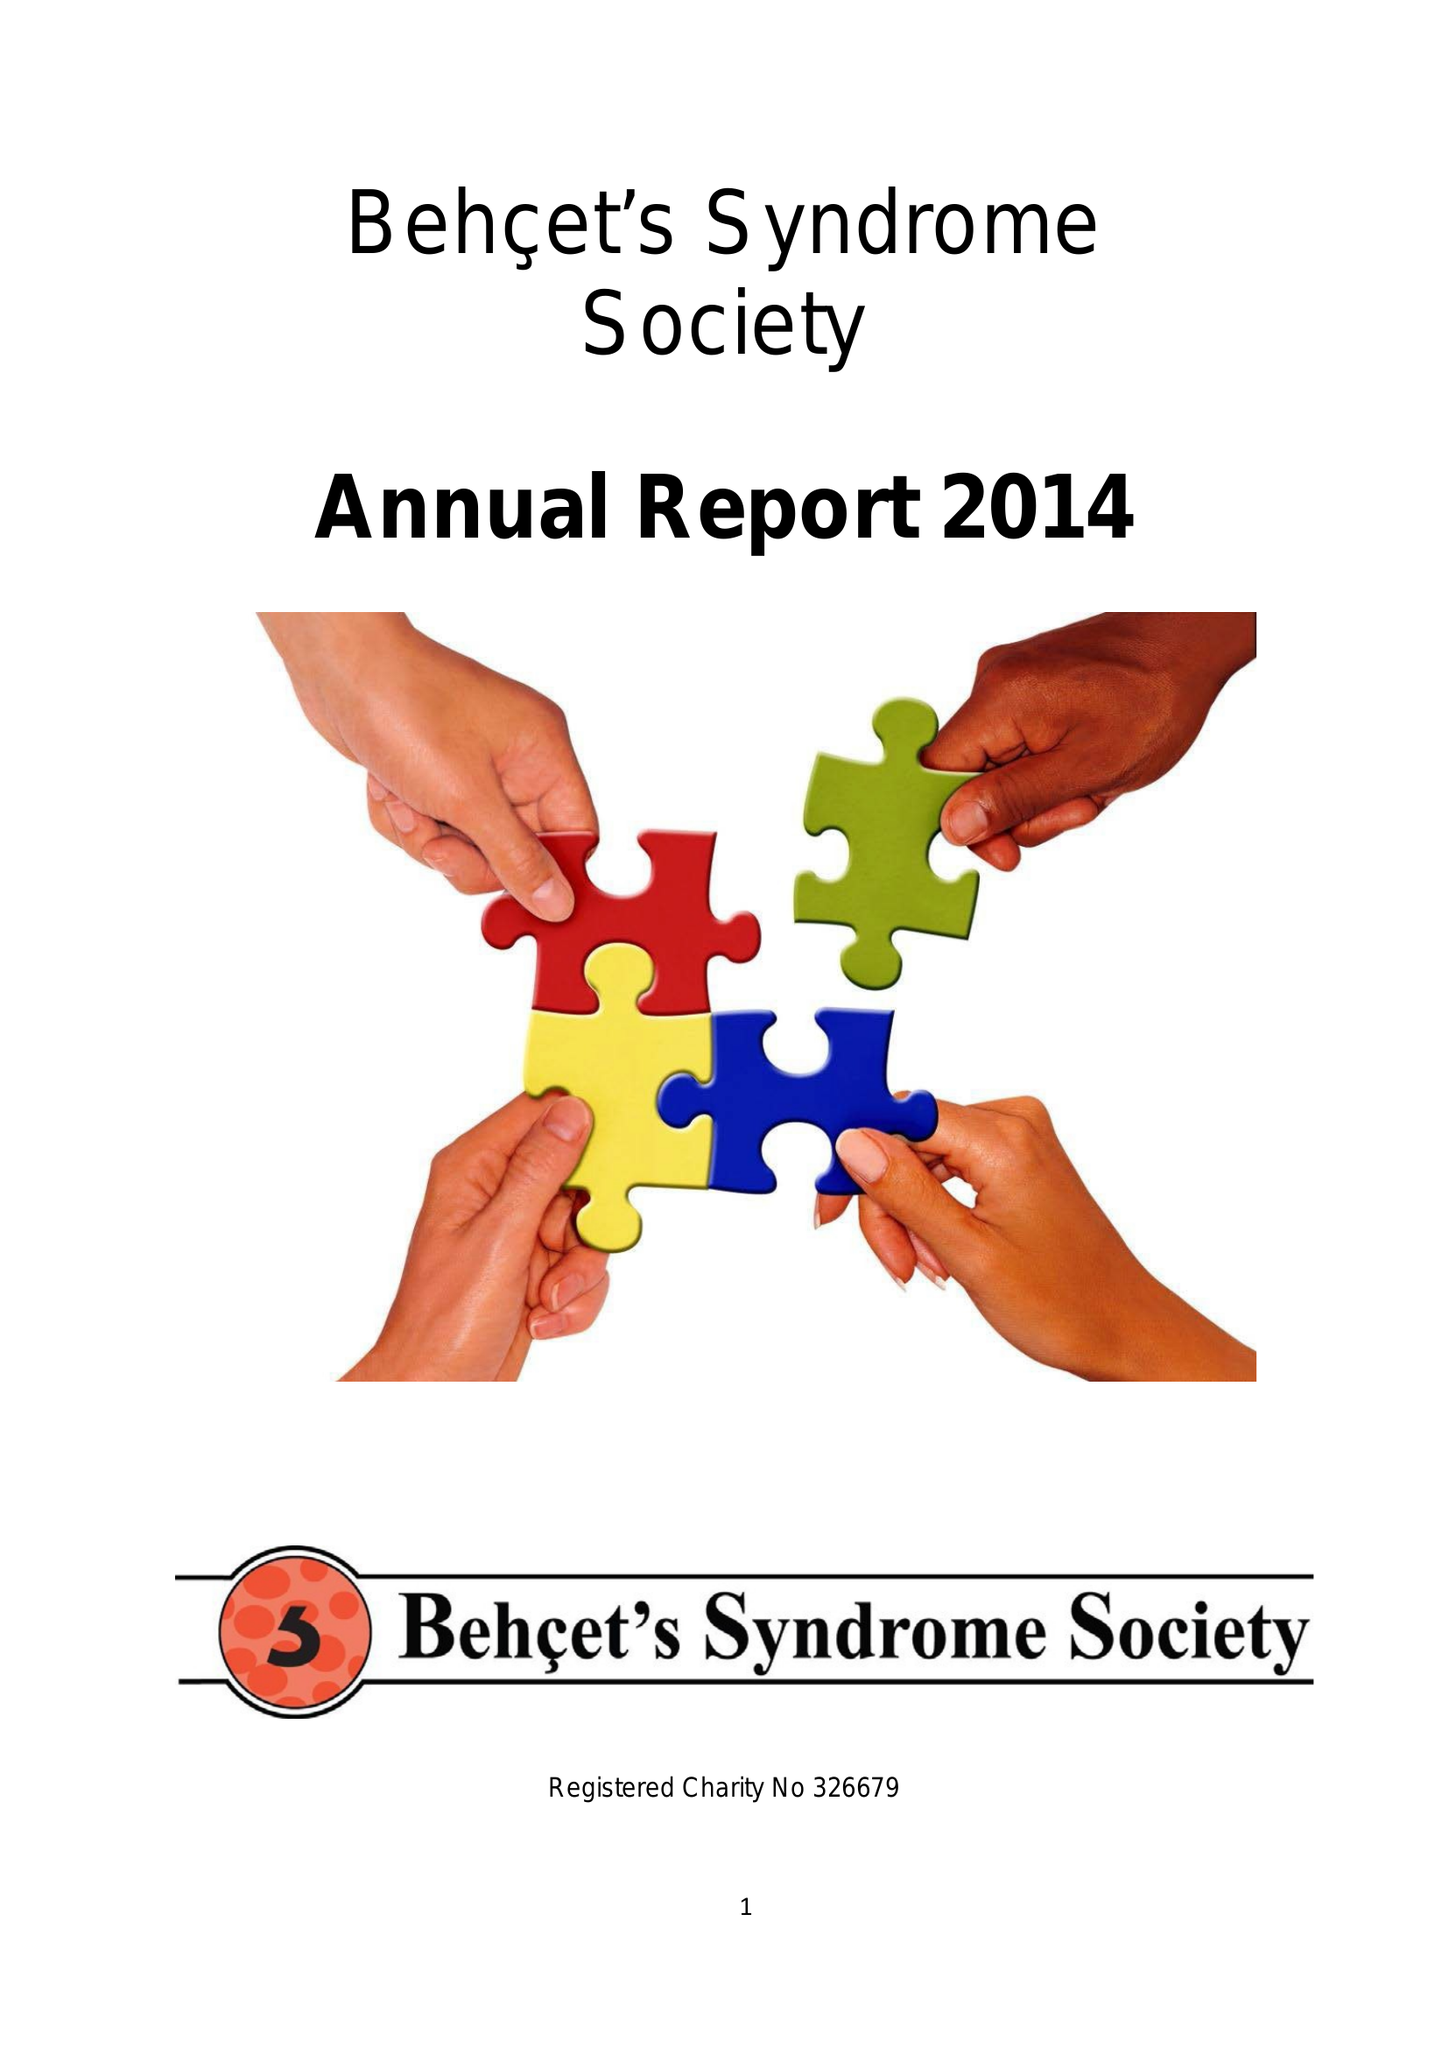What is the value for the address__postcode?
Answer the question using a single word or phrase. EC1V 2NX 